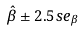<formula> <loc_0><loc_0><loc_500><loc_500>\hat { \beta } \pm 2 . 5 s e _ { \beta }</formula> 